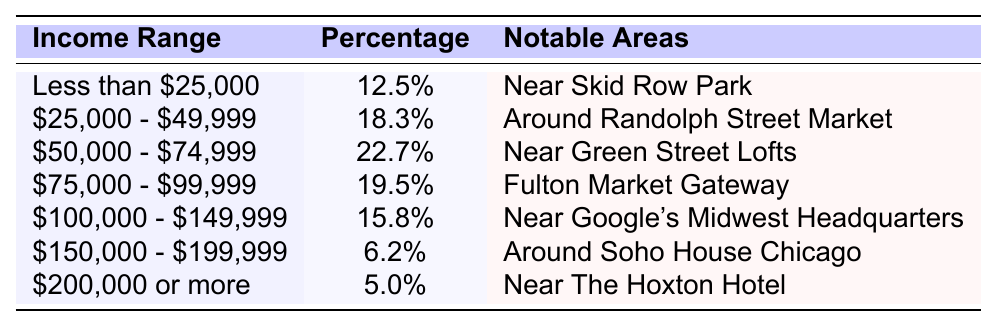What is the percentage of Fulton Market residents earning less than $25,000? The table shows that the income range "Less than $25,000" has a percentage of 12.5%.
Answer: 12.5% What notable area is associated with residents earning between $50,000 and $74,999? According to the table, the area noted for residents earning between $50,000 and $74,999 is "Near Green Street Lofts."
Answer: Near Green Street Lofts How many income ranges have a percentage higher than 15%? The income ranges with percentages higher than 15% are "Less than $25,000" (12.5%), "$25,000 - $49,999" (18.3%), "$50,000 - $74,999" (22.7%), "$75,000 - $99,999" (19.5%), and "$100,000 - $149,999" (15.8%). This total gives us 4 income ranges over 15%.
Answer: 4 What is the income range with the lowest percentage? The table indicates the income range with the lowest percentage is "$200,000 or more," which has only 5% of residents.
Answer: $200,000 or more If we sum the percentages of residents earning between $75,000 and $149,999, what do we get? The ranges between $75,000 and $149,999 are "$75,000 - $99,999" (19.5%) and "$100,000 - $149,999" (15.8%). Adding those percentages gives 19.5 + 15.8 = 35.3%.
Answer: 35.3% What percentage of residents earns $150,000 or more? According to the table, the percentage of residents earning $150,000 or more is the sum of the percentages for the ranges "$150,000 - $199,999" (6.2%) and "$200,000 or more" (5.0%); therefore, it is 6.2 + 5.0 = 11.2%.
Answer: 11.2% Which income range has a notable area associated with Google's Midwest Headquarters? The income range "$100,000 - $149,999" corresponds to the notable area "Near Google's Midwest Headquarters."
Answer: $100,000 - $149,999 What is the combined percentage of residents earning between $25,000 and $74,999? The percentages for the ranges are "$25,000 - $49,999" (18.3%) and "$50,000 - $74,999" (22.7%). Their sum is 18.3 + 22.7 = 41.0%.
Answer: 41.0% Is there any income range where the percentage of residents is exactly 6%? In the table, the percentages for all income ranges are higher than 6%, so there isn't any range with exactly 6%.
Answer: No What is the notable area for the highest percentage of residents? The highest percentage is 22.7% for the income range "$50,000 - $74,999," which is notable in "Near Green Street Lofts."
Answer: Near Green Street Lofts 